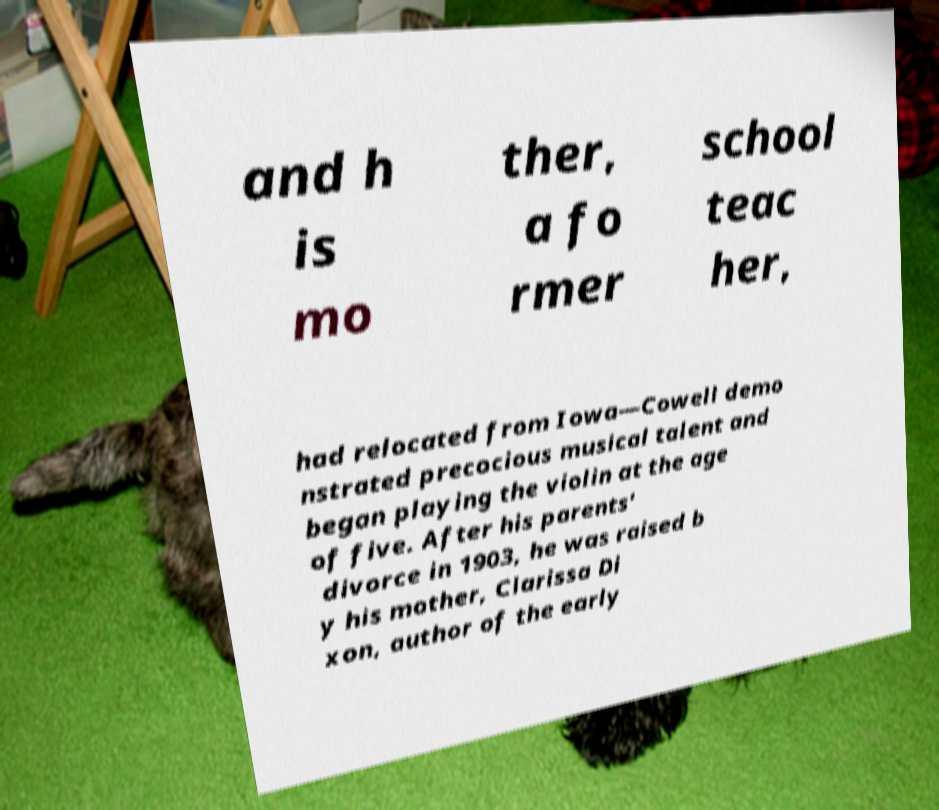What messages or text are displayed in this image? I need them in a readable, typed format. and h is mo ther, a fo rmer school teac her, had relocated from Iowa—Cowell demo nstrated precocious musical talent and began playing the violin at the age of five. After his parents' divorce in 1903, he was raised b y his mother, Clarissa Di xon, author of the early 